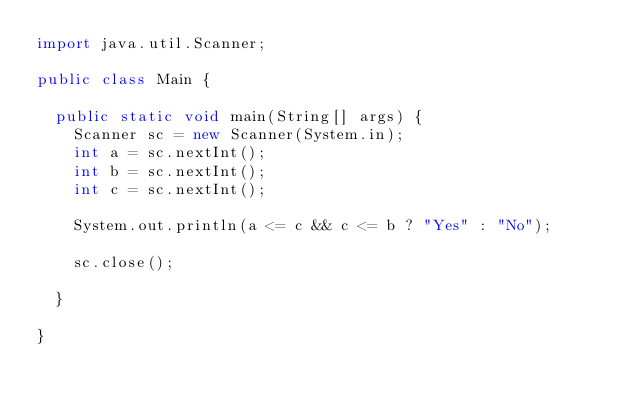Convert code to text. <code><loc_0><loc_0><loc_500><loc_500><_Java_>import java.util.Scanner;

public class Main {

	public static void main(String[] args) {
		Scanner sc = new Scanner(System.in);
		int a = sc.nextInt();
		int b = sc.nextInt();
		int c = sc.nextInt();

		System.out.println(a <= c && c <= b ? "Yes" : "No");

		sc.close();

	}

}</code> 